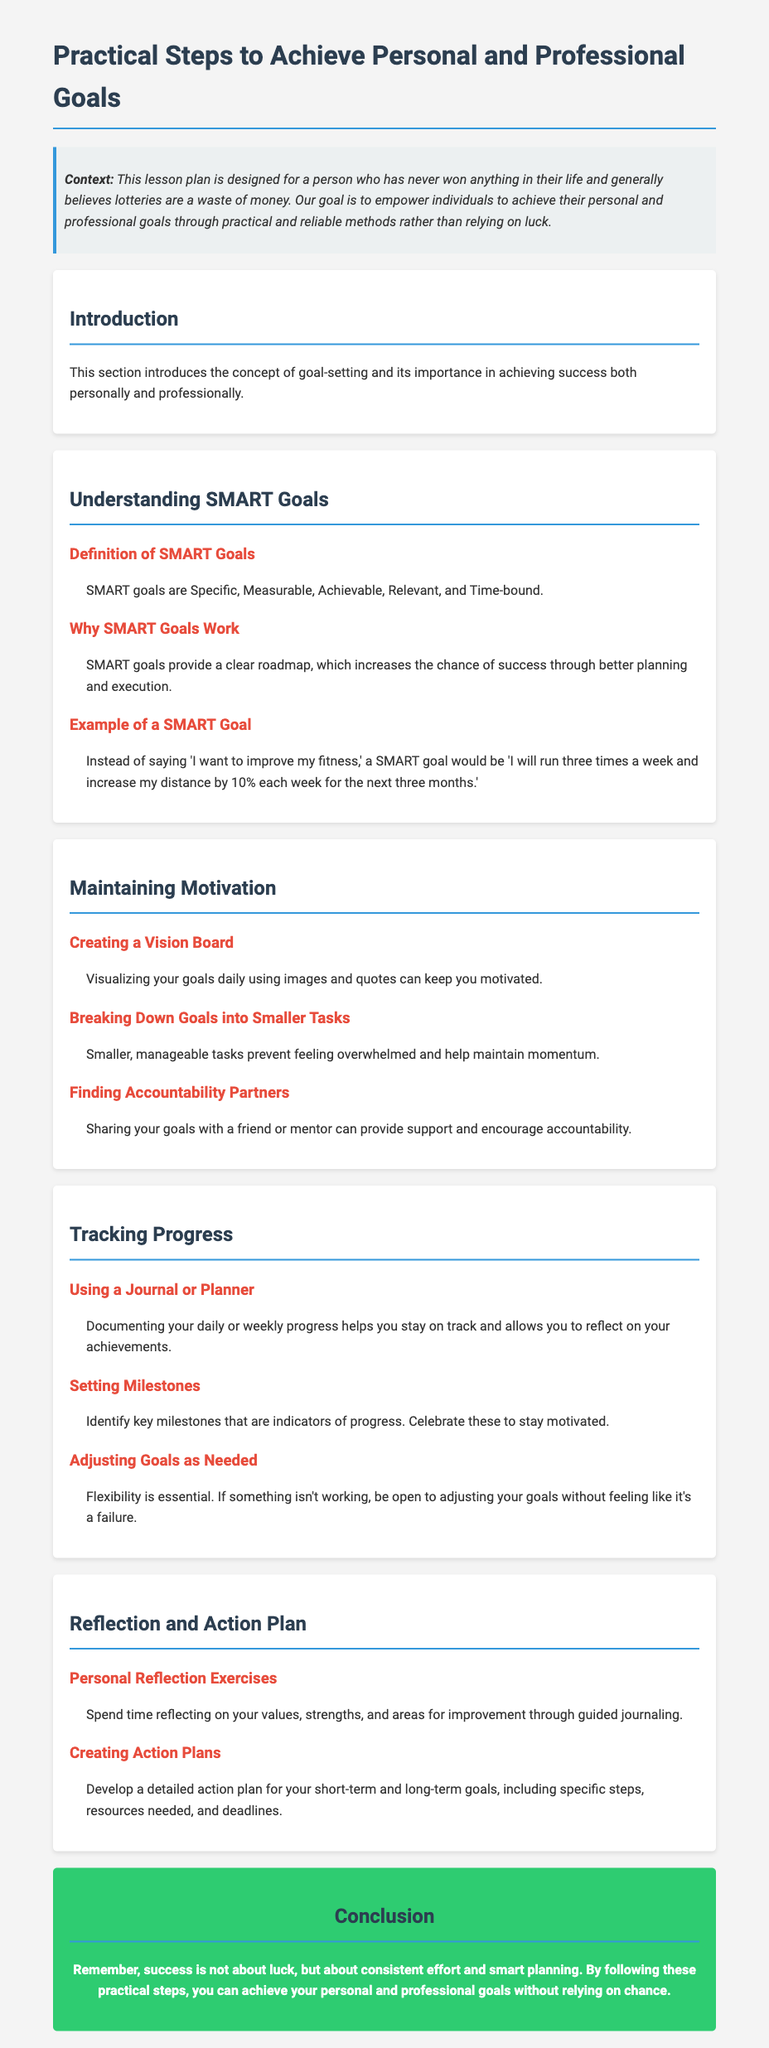What are SMART goals? SMART goals are defined in the section as Specific, Measurable, Achievable, Relevant, and Time-bound.
Answer: Specific, Measurable, Achievable, Relevant, Time-bound What is the purpose of a vision board? The section on maintaining motivation states that visualizing your goals daily using images and quotes can keep you motivated.
Answer: Keep you motivated What should you document to track progress? The document suggests using a journal or planner to document your daily or weekly progress.
Answer: Journal or planner What type of exercises are included in the Reflection section? Personal reflection exercises are mentioned, focusing on values, strengths, and areas for improvement.
Answer: Personal reflection exercises What is the key benefit of setting milestones? According to the tracking progress section, identifying key milestones acts as indicators of progress and helps maintain motivation.
Answer: Indicators of progress What is emphasized as essential when adjusting goals? The document highlights that flexibility is essential when adjusting goals.
Answer: Flexibility What technique involves breaking goals into smaller tasks? The section on maintaining motivation refers to breaking down goals into smaller tasks to prevent feeling overwhelmed.
Answer: Breaking down goals What is included in the action plans for goals? Creating action plans involves including specific steps, resources needed, and deadlines.
Answer: Specific steps, resources needed, deadlines 